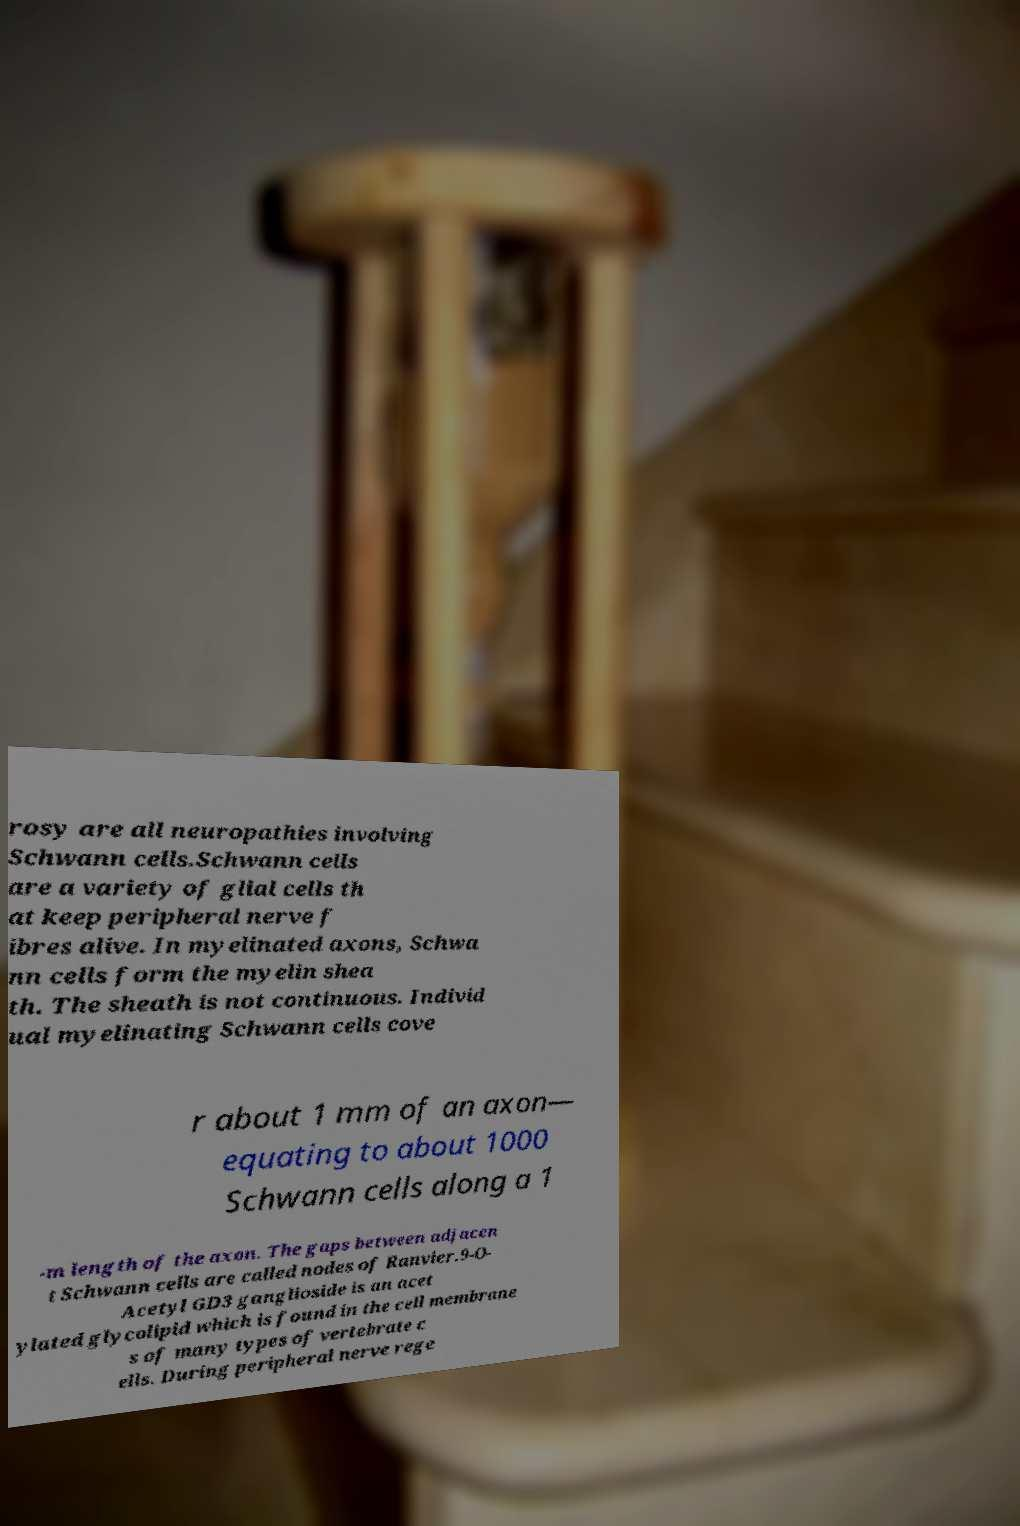What messages or text are displayed in this image? I need them in a readable, typed format. rosy are all neuropathies involving Schwann cells.Schwann cells are a variety of glial cells th at keep peripheral nerve f ibres alive. In myelinated axons, Schwa nn cells form the myelin shea th. The sheath is not continuous. Individ ual myelinating Schwann cells cove r about 1 mm of an axon— equating to about 1000 Schwann cells along a 1 -m length of the axon. The gaps between adjacen t Schwann cells are called nodes of Ranvier.9-O- Acetyl GD3 ganglioside is an acet ylated glycolipid which is found in the cell membrane s of many types of vertebrate c ells. During peripheral nerve rege 